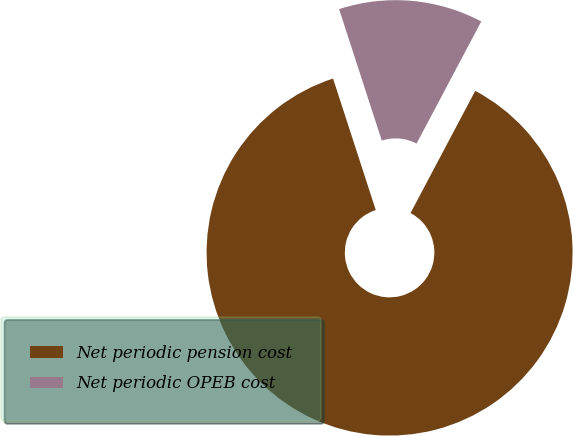<chart> <loc_0><loc_0><loc_500><loc_500><pie_chart><fcel>Net periodic pension cost<fcel>Net periodic OPEB cost<nl><fcel>87.25%<fcel>12.75%<nl></chart> 